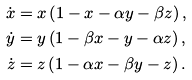<formula> <loc_0><loc_0><loc_500><loc_500>\dot { x } & = x \left ( 1 - x - \alpha y - \beta z \right ) , \\ \dot { y } & = y \left ( 1 - \beta x - y - \alpha z \right ) , \\ \dot { z } & = z \left ( 1 - \alpha x - \beta y - z \right ) .</formula> 